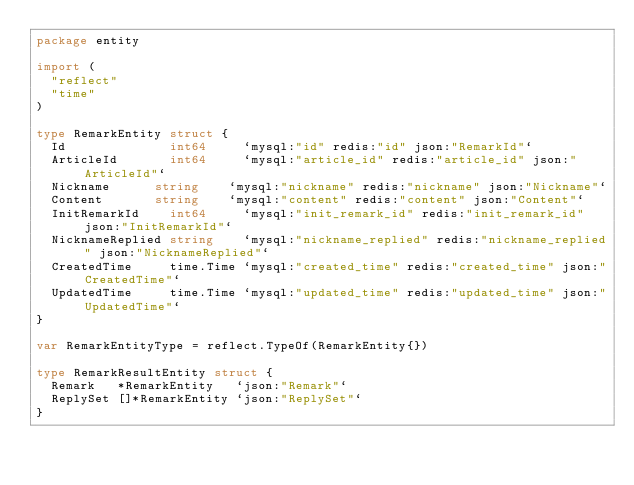<code> <loc_0><loc_0><loc_500><loc_500><_Go_>package entity

import (
	"reflect"
	"time"
)

type RemarkEntity struct {
	Id              int64     `mysql:"id" redis:"id" json:"RemarkId"`
	ArticleId  	    int64     `mysql:"article_id" redis:"article_id" json:"ArticleId"`
	Nickname 	    string    `mysql:"nickname" redis:"nickname" json:"Nickname"`
	Content 	    string    `mysql:"content" redis:"content" json:"Content"`
	InitRemarkId    int64     `mysql:"init_remark_id" redis:"init_remark_id" json:"InitRemarkId"`
	NicknameReplied string    `mysql:"nickname_replied" redis:"nickname_replied" json:"NicknameReplied"`
	CreatedTime     time.Time `mysql:"created_time" redis:"created_time" json:"CreatedTime"`
	UpdatedTime     time.Time `mysql:"updated_time" redis:"updated_time" json:"UpdatedTime"`
}

var RemarkEntityType = reflect.TypeOf(RemarkEntity{})

type RemarkResultEntity struct {
	Remark   *RemarkEntity   `json:"Remark"`
	ReplySet []*RemarkEntity `json:"ReplySet"`
}
</code> 